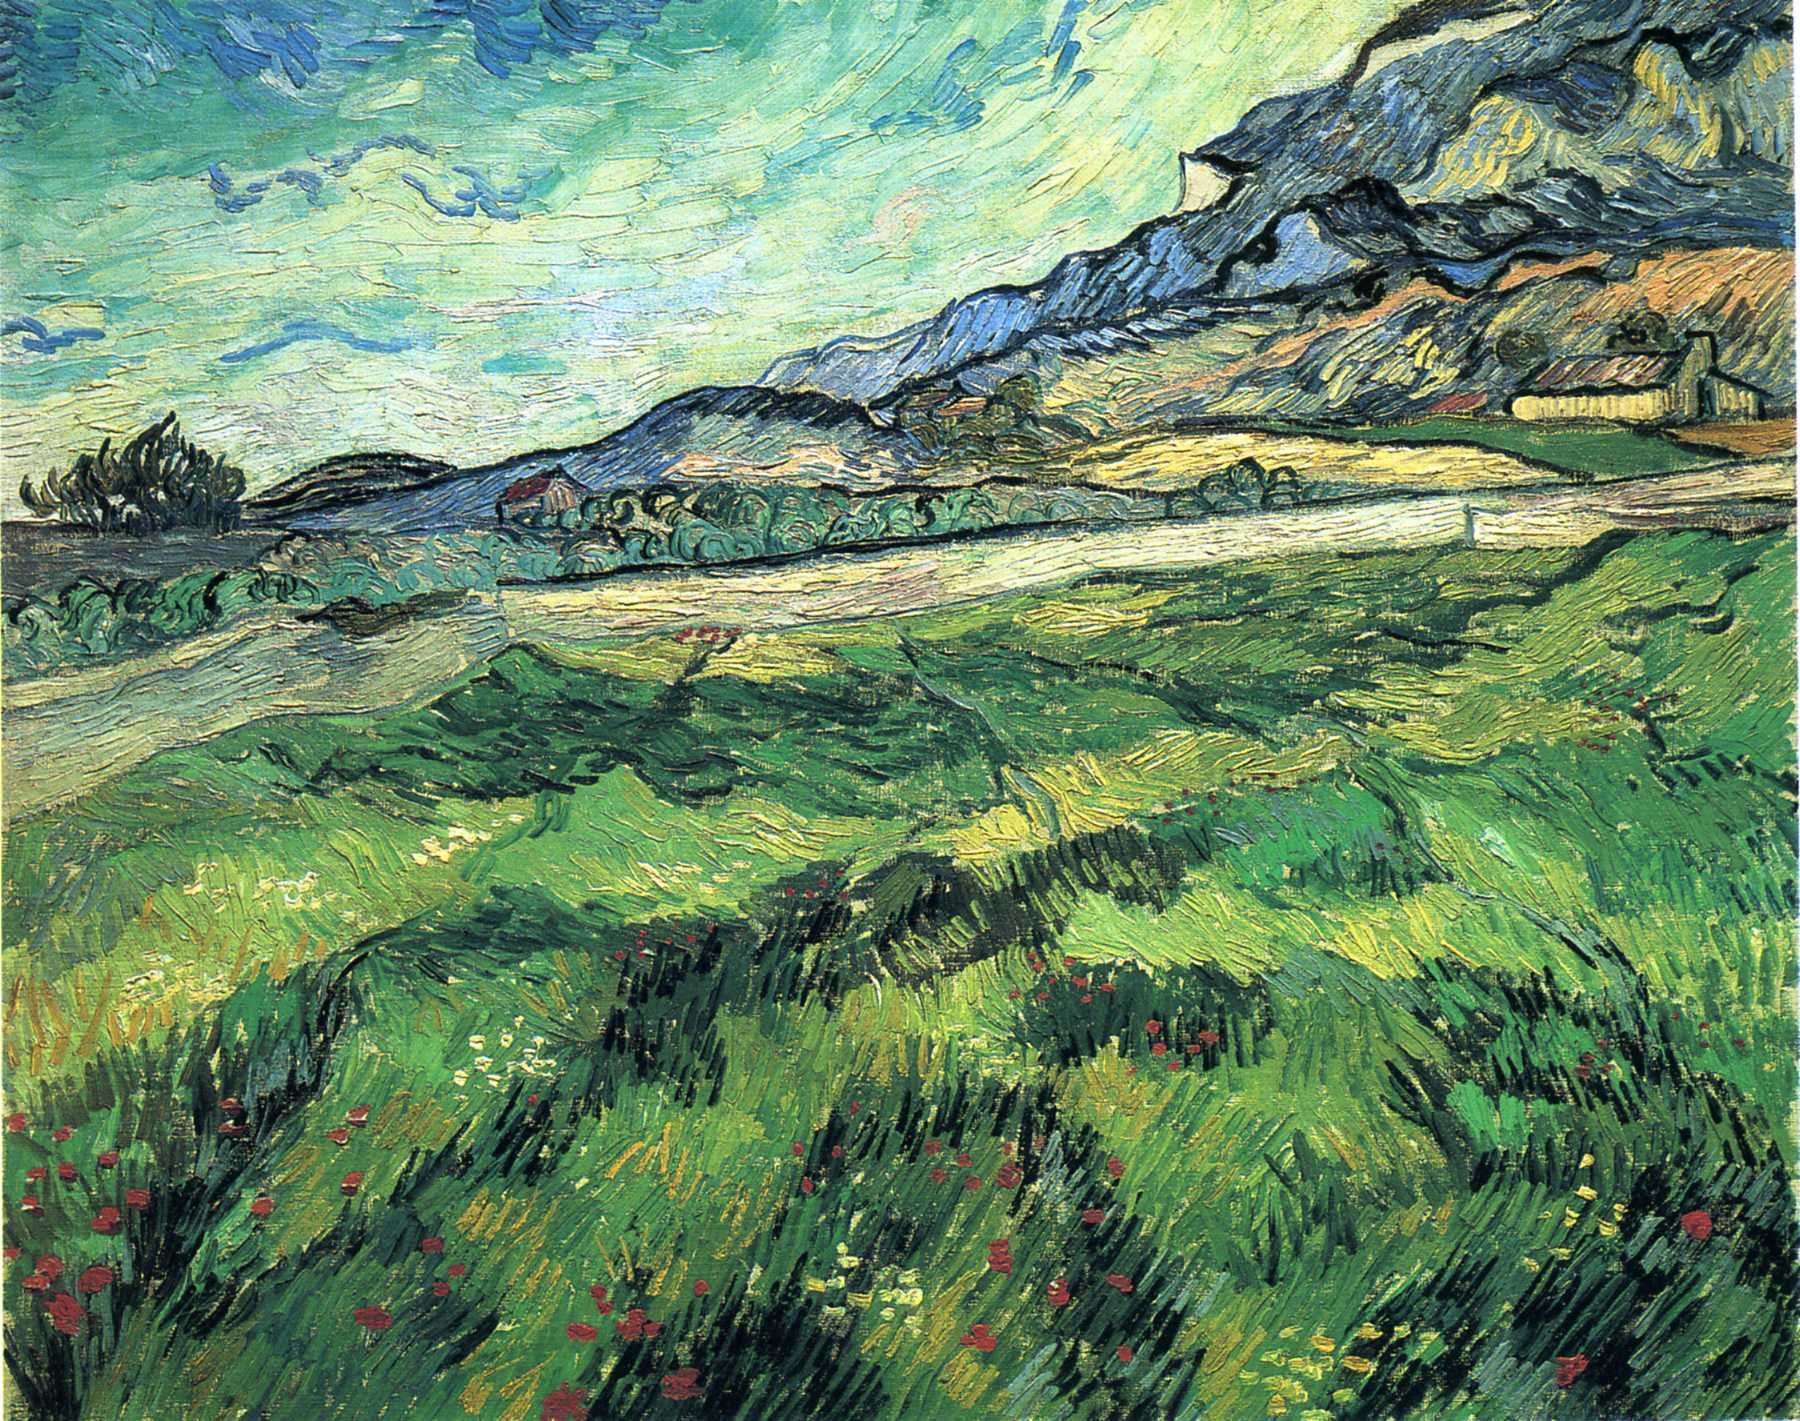What specific artistic techniques characterize Van Gogh’s style in this painting? This painting is characterized by Van Gogh's use of bold, visible brushstrokes and vibrant colors. The technique known as impasto is prominent, where paint is laid on thickly so that the texture of brush or palette knife strokes is visible. The swirling patterns in the sky and the dynamic lines in the field create a sense of movement, which is a key attribute of Van Gogh's work. His color palette, filled with intense greens, blues, and yellows, helps evoke emotional responses and brings the scene to life with a sense of immediacy and vigor. If this painting were part of a story, what role would it play and how would it influence the characters? In a narrative, this painting could serve as a pivotal setting where characters come to find solace, inspiration, or revelation. It might be a place where a protagonist seeks refuge from the chaos of life, finding peace in the rhythmic sway of the wildflowers and the majestic mountain. Alternatively, this scene could be the backdrop for a moment of profound introspection, where characters confront their inner fears and desires, mirroring the turbulent yet beautiful sky. The vivid environment might also provoke a creative breakthrough for an artist or writer character, whose emotional state echoes the expressive brushstrokes and vibrant hues. Ultimately, this painting would act as a catalyst for personal transformation, offering a serene yet emotionally charged space for the unfolding of crucial plot developments. 